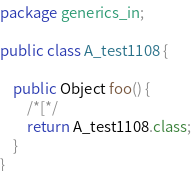<code> <loc_0><loc_0><loc_500><loc_500><_Java_>package generics_in;

public class A_test1108 {

    public Object foo() {
        /*[*/
        return A_test1108.class;
    }
}
</code> 